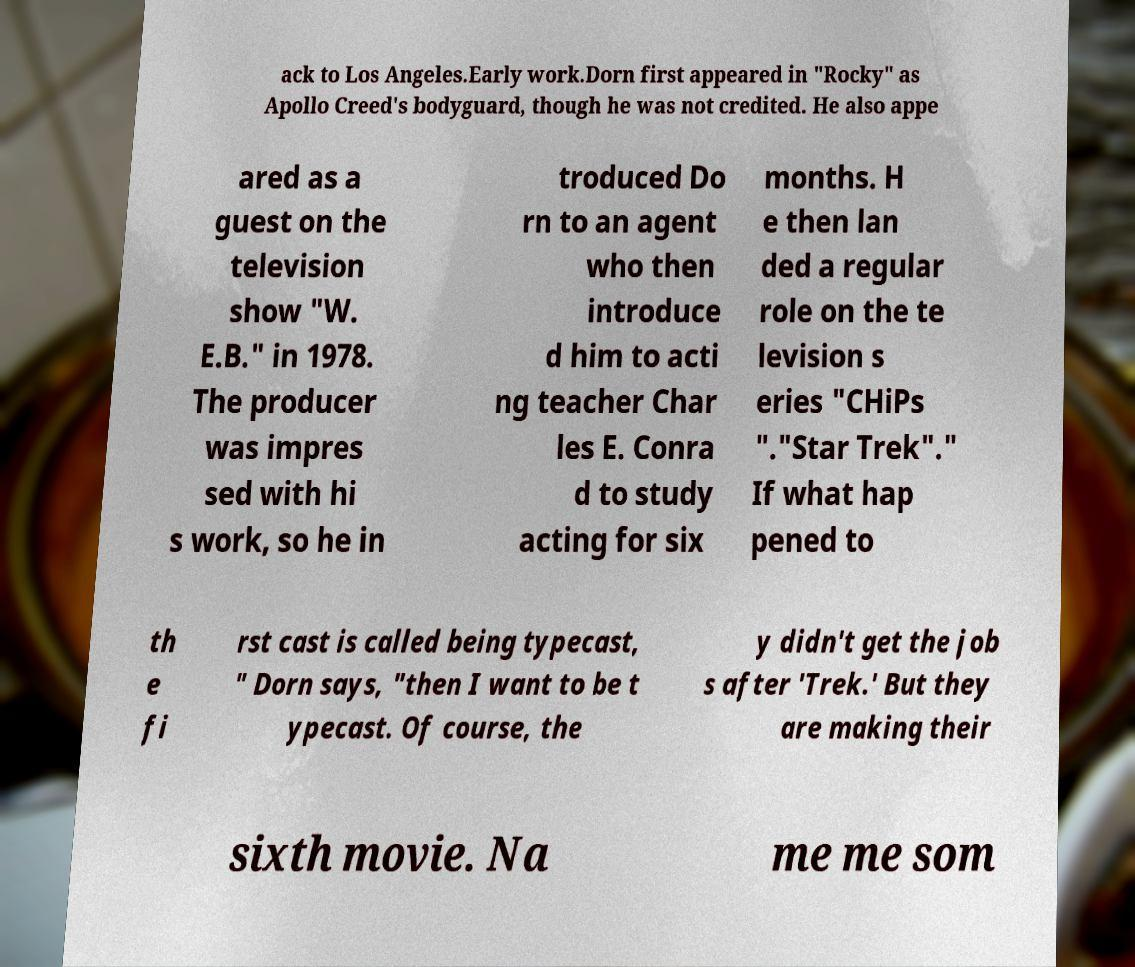Can you accurately transcribe the text from the provided image for me? ack to Los Angeles.Early work.Dorn first appeared in "Rocky" as Apollo Creed's bodyguard, though he was not credited. He also appe ared as a guest on the television show "W. E.B." in 1978. The producer was impres sed with hi s work, so he in troduced Do rn to an agent who then introduce d him to acti ng teacher Char les E. Conra d to study acting for six months. H e then lan ded a regular role on the te levision s eries "CHiPs "."Star Trek"." If what hap pened to th e fi rst cast is called being typecast, " Dorn says, "then I want to be t ypecast. Of course, the y didn't get the job s after 'Trek.' But they are making their sixth movie. Na me me som 